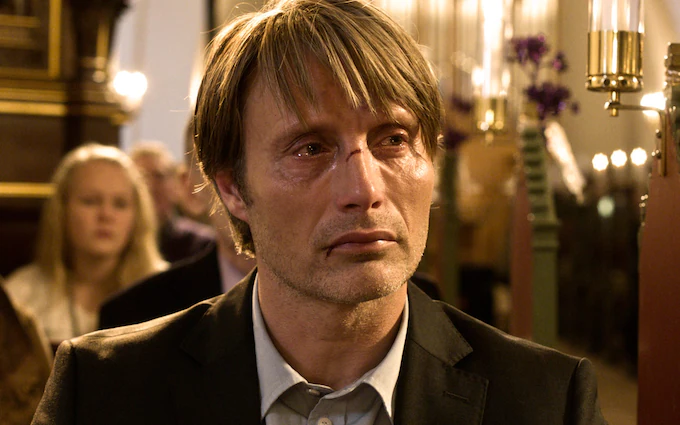Create a detailed and imaginative scenario involving the man. In a grand, timeless church echoing with the whispers of history, the man stands alone, lost in a whirlpool of memories. He is Dr. Jonathan Everhart, a renowned neuroscientist who has spent his life deciphering the mysteries of the human brain. The church is not just a sanctuary but a portal to his past. Fifteen years ago, he stood in the sharegpt4v/same spot, waiting for his bride, who never appeared. She vanished without a trace, leaving Dr. Everhart to drown in an ocean of unanswered questions and overwhelming grief. Fast forward to the present, Jonathan has recently discovered a groundbreaking connection between human consciousness and a hidden layer of neural networks—one that might explain unexplainable phenomena. His research has led him back to this church, where he believes the key to uncovering the truth about his lost love lies. The emotions boiling within him are not just from sorrow but also a burning hope that he might finally find answers, that he might see her again, even if just in the labyrinth of his mind. 